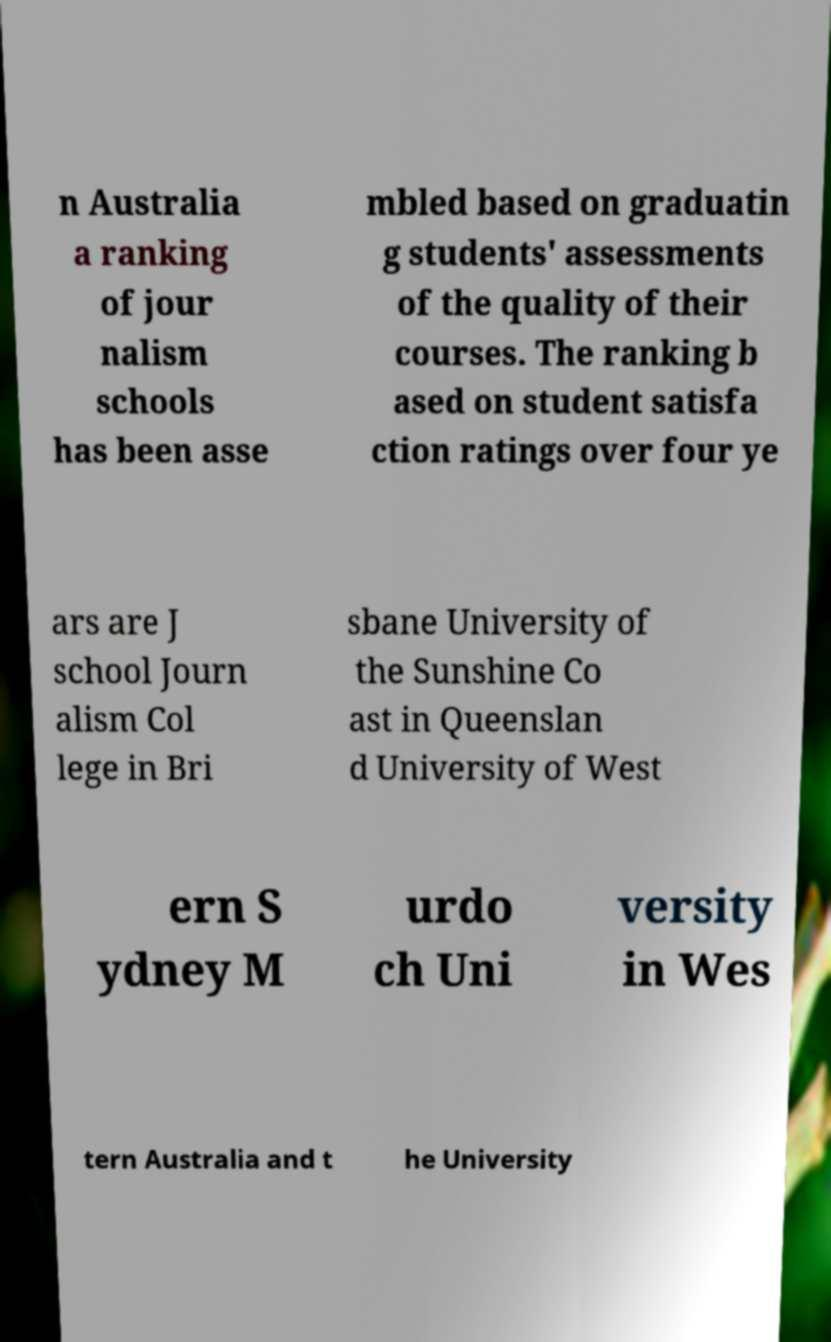Could you assist in decoding the text presented in this image and type it out clearly? n Australia a ranking of jour nalism schools has been asse mbled based on graduatin g students' assessments of the quality of their courses. The ranking b ased on student satisfa ction ratings over four ye ars are J school Journ alism Col lege in Bri sbane University of the Sunshine Co ast in Queenslan d University of West ern S ydney M urdo ch Uni versity in Wes tern Australia and t he University 